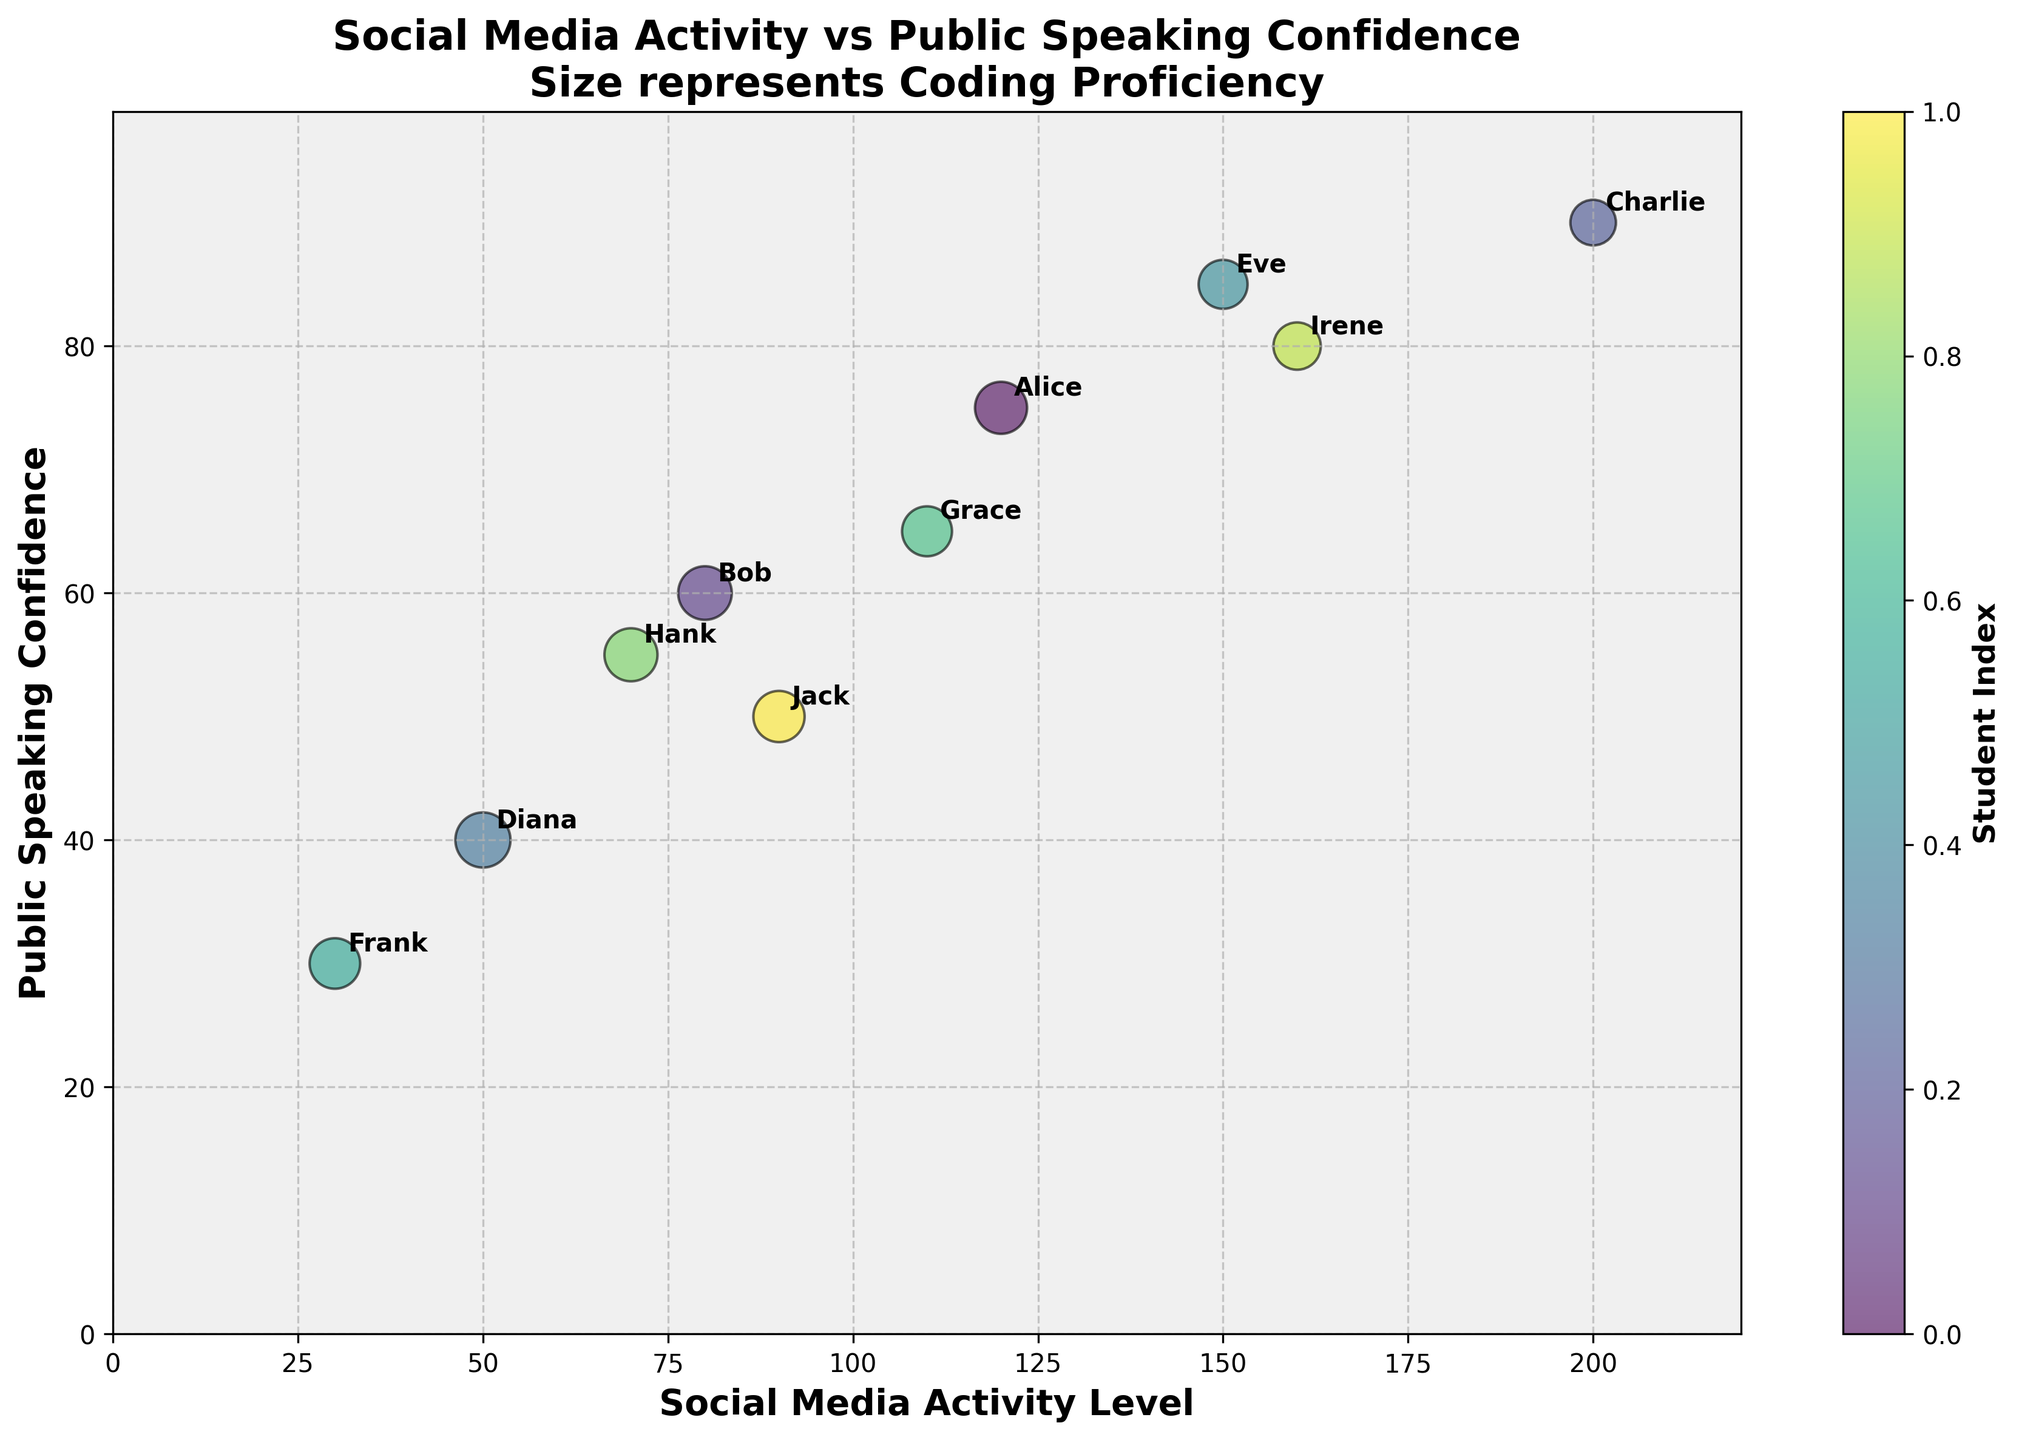What's the title of the chart? The title is typically displayed at the top of the chart and describes what the chart is about.
Answer: Social Media Activity vs Public Speaking Confidence What are the x- and y-axis labels? The x-axis label describes the data plotted along the horizontal axis, and the y-axis label describes the data on the vertical axis.
Answer: Social Media Activity Level and Public Speaking Confidence How many students are represented in the chart? Each bubble represents one student, and we can see how many bubbles are plotted on the chart.
Answer: 10 Which student has the highest public speaking confidence? Look at the y-axis values and find the student associated with the highest value.
Answer: Charlie What is the public speaking confidence level of the student with the highest social media activity level? Identify the highest x-axis value, then check the corresponding y-axis value.
Answer: 90 Who has a coding proficiency larger than 90? Compare the sizes of the bubbles and identify the ones that are comparatively larger, then refer to the student labels.
Answer: Diana Which student has the lowest social media activity level and what is their coding proficiency? Locate the smallest x-axis value and find the corresponding size of the bubble.
Answer: Frank, 80 Who are the students with a public speaking confidence level greater than 70? Check the y-axis values greater than 70 and refer to the student labels.
Answer: Alice, Charlie, Eve, Irene What is the social media activity level and coding proficiency of Eve? Locate the bubble labeled Eve and determine its position on the x-axis and size.
Answer: 150, 75 Comparing Irene and Jack, who has a higher public speaking confidence and by how much? Identify the y-axis values for Irene and Jack, and calculate the difference.
Answer: Irene by 30 